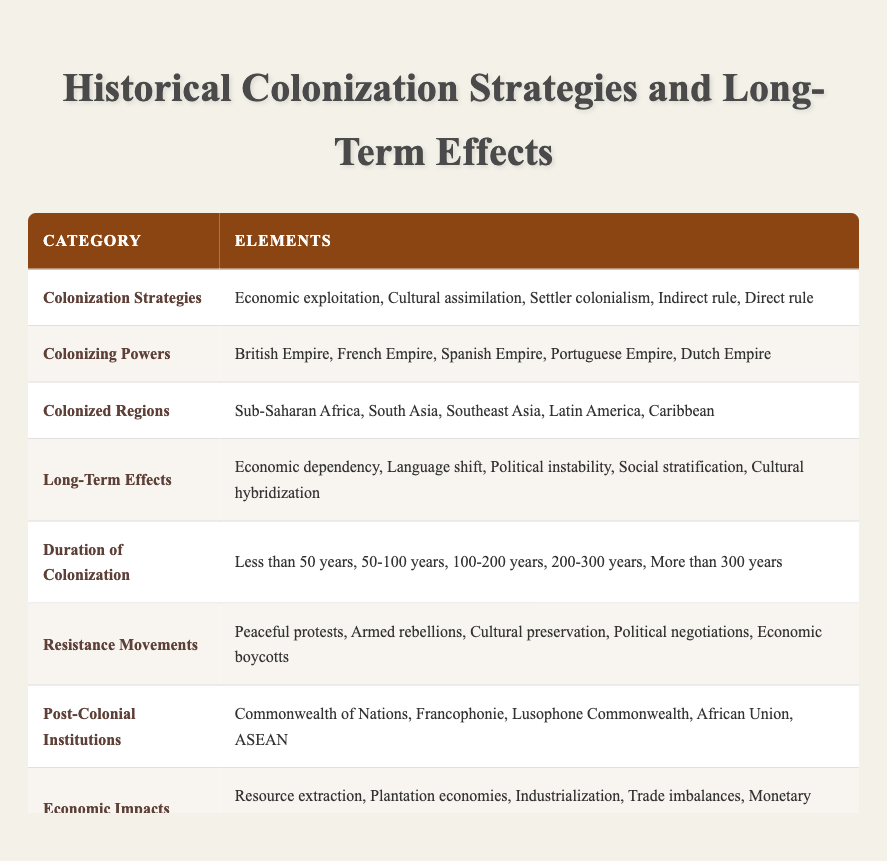What are the colonization strategies listed in the table? The table directly states the colonization strategies under the "Colonization Strategies" category, which includes Economic exploitation, Cultural assimilation, Settler colonialism, Indirect rule, and Direct rule.
Answer: Economic exploitation, Cultural assimilation, Settler colonialism, Indirect rule, Direct rule Which colonizing power is associated with Southeast Asia? The table does not specify a direct relationship between colonizing powers and regions, but it lists the colonizing powers as the British Empire, French Empire, Spanish Empire, Portuguese Empire, and Dutch Empire. Southeast Asia typically falls under the influence of the Dutch Empire and the British Empire.
Answer: Dutch Empire and British Empire Is "Cultural hybridization" listed as a long-term effect of colonization? By examining the "Long-Term Effects" category in the table, we can see that "Cultural hybridization" is indeed present among the listed effects.
Answer: Yes What is the duration range that includes centuries of colonization? Looking at the "Duration of Colonization" category, the ranges that include centuries are "100-200 years" and "200-300 years," as these categories specify periods that are in the hundreds.
Answer: 100-200 years and 200-300 years How many resistance movement types are mentioned in the table? The "Resistance Movements" category lists five types: Peaceful protests, Armed rebellions, Cultural preservation, Political negotiations, and Economic boycotts. Therefore, we simply count these items for the total.
Answer: 5 Which post-colonial institution is relevant to the French-speaking countries? The "Post-Colonial Institutions" category includes the Francophonie, which directly relates to French-speaking nations and their cooperation and cultural ties.
Answer: Francophonie What are the environmental impacts of colonization listed? The environmental impacts listed under the "Environmental Impacts" category are Deforestation, Agricultural changes, Introduction of invasive species, Mining and pollution, and Altered ecosystems. Each of these impacts reflects common environmental consequences of colonial activities.
Answer: Deforestation, Agricultural changes, Introduction of invasive species, Mining and pollution, Altered ecosystems Which colonizing powers are associated with political instability? Political instability, noted as a long-term effect, can generally be linked to various colonizing powers. However, there are no specific colonizing powers listed next to this effect in the table, necessitating knowledge of history for specific associations.
Answer: Not specified What is the average duration of the colonization periods listed in the table? First, we note the numerical values associated with the durations: Less than 50 years (assume 25 years for average), 50-100 years (average 75), 100-200 years (average 150), 200-300 years (average 250), and More than 300 years (assume 350 for average). Summing these gives 25 + 75 + 150 + 250 + 350 = 850 years. There are 5 categories, so dividing gives us an average duration of 850/5 = 170 years.
Answer: 170 years 